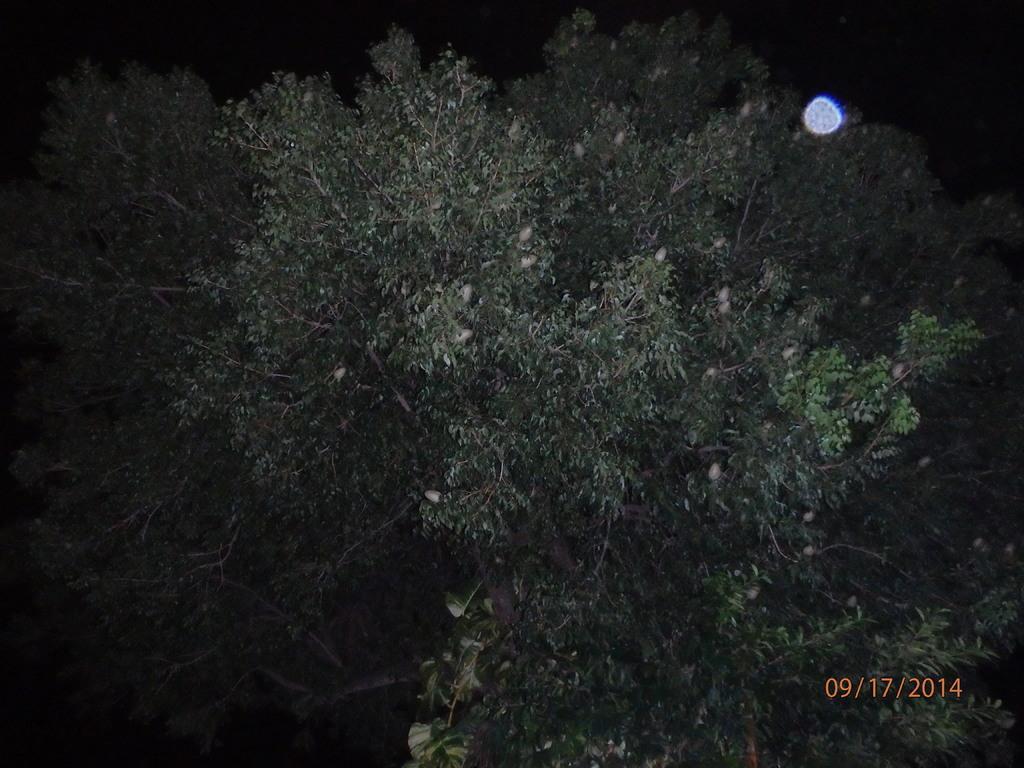Please provide a concise description of this image. This picture contains trees. At the top of the picture, we see the moon. In the background, it is black in color. 